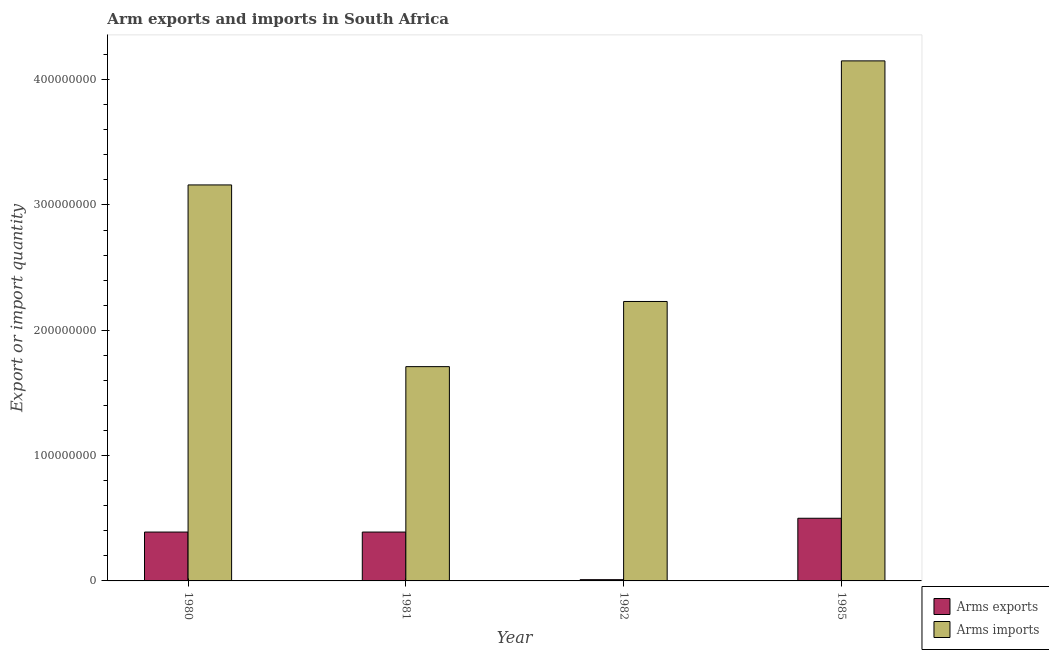How many groups of bars are there?
Provide a short and direct response. 4. Are the number of bars per tick equal to the number of legend labels?
Give a very brief answer. Yes. What is the label of the 3rd group of bars from the left?
Provide a short and direct response. 1982. What is the arms imports in 1981?
Make the answer very short. 1.71e+08. Across all years, what is the maximum arms imports?
Your response must be concise. 4.15e+08. Across all years, what is the minimum arms imports?
Offer a very short reply. 1.71e+08. In which year was the arms exports maximum?
Your answer should be very brief. 1985. In which year was the arms exports minimum?
Provide a short and direct response. 1982. What is the total arms imports in the graph?
Offer a terse response. 1.12e+09. What is the difference between the arms exports in 1980 and that in 1982?
Your answer should be very brief. 3.80e+07. What is the difference between the arms exports in 1981 and the arms imports in 1982?
Your answer should be compact. 3.80e+07. What is the average arms exports per year?
Give a very brief answer. 3.22e+07. In the year 1985, what is the difference between the arms exports and arms imports?
Your response must be concise. 0. In how many years, is the arms imports greater than 20000000?
Offer a terse response. 4. What is the ratio of the arms imports in 1982 to that in 1985?
Provide a succinct answer. 0.54. Is the arms exports in 1980 less than that in 1985?
Keep it short and to the point. Yes. What is the difference between the highest and the second highest arms exports?
Provide a short and direct response. 1.10e+07. What is the difference between the highest and the lowest arms imports?
Your answer should be very brief. 2.44e+08. In how many years, is the arms exports greater than the average arms exports taken over all years?
Make the answer very short. 3. What does the 1st bar from the left in 1981 represents?
Provide a succinct answer. Arms exports. What does the 2nd bar from the right in 1980 represents?
Give a very brief answer. Arms exports. How many bars are there?
Offer a terse response. 8. How many years are there in the graph?
Make the answer very short. 4. Are the values on the major ticks of Y-axis written in scientific E-notation?
Your answer should be compact. No. Does the graph contain any zero values?
Provide a short and direct response. No. Does the graph contain grids?
Your answer should be very brief. No. Where does the legend appear in the graph?
Keep it short and to the point. Bottom right. How many legend labels are there?
Keep it short and to the point. 2. How are the legend labels stacked?
Your answer should be very brief. Vertical. What is the title of the graph?
Your response must be concise. Arm exports and imports in South Africa. Does "Primary completion rate" appear as one of the legend labels in the graph?
Keep it short and to the point. No. What is the label or title of the X-axis?
Offer a terse response. Year. What is the label or title of the Y-axis?
Make the answer very short. Export or import quantity. What is the Export or import quantity of Arms exports in 1980?
Your answer should be compact. 3.90e+07. What is the Export or import quantity of Arms imports in 1980?
Your response must be concise. 3.16e+08. What is the Export or import quantity of Arms exports in 1981?
Ensure brevity in your answer.  3.90e+07. What is the Export or import quantity in Arms imports in 1981?
Provide a short and direct response. 1.71e+08. What is the Export or import quantity in Arms exports in 1982?
Give a very brief answer. 1.00e+06. What is the Export or import quantity of Arms imports in 1982?
Your answer should be compact. 2.23e+08. What is the Export or import quantity in Arms exports in 1985?
Your answer should be very brief. 5.00e+07. What is the Export or import quantity in Arms imports in 1985?
Ensure brevity in your answer.  4.15e+08. Across all years, what is the maximum Export or import quantity in Arms imports?
Give a very brief answer. 4.15e+08. Across all years, what is the minimum Export or import quantity in Arms exports?
Keep it short and to the point. 1.00e+06. Across all years, what is the minimum Export or import quantity in Arms imports?
Provide a short and direct response. 1.71e+08. What is the total Export or import quantity in Arms exports in the graph?
Keep it short and to the point. 1.29e+08. What is the total Export or import quantity in Arms imports in the graph?
Offer a terse response. 1.12e+09. What is the difference between the Export or import quantity of Arms exports in 1980 and that in 1981?
Ensure brevity in your answer.  0. What is the difference between the Export or import quantity in Arms imports in 1980 and that in 1981?
Your answer should be compact. 1.45e+08. What is the difference between the Export or import quantity of Arms exports in 1980 and that in 1982?
Make the answer very short. 3.80e+07. What is the difference between the Export or import quantity of Arms imports in 1980 and that in 1982?
Provide a short and direct response. 9.30e+07. What is the difference between the Export or import quantity of Arms exports in 1980 and that in 1985?
Ensure brevity in your answer.  -1.10e+07. What is the difference between the Export or import quantity in Arms imports in 1980 and that in 1985?
Provide a short and direct response. -9.90e+07. What is the difference between the Export or import quantity of Arms exports in 1981 and that in 1982?
Your response must be concise. 3.80e+07. What is the difference between the Export or import quantity in Arms imports in 1981 and that in 1982?
Provide a short and direct response. -5.20e+07. What is the difference between the Export or import quantity in Arms exports in 1981 and that in 1985?
Give a very brief answer. -1.10e+07. What is the difference between the Export or import quantity in Arms imports in 1981 and that in 1985?
Your answer should be very brief. -2.44e+08. What is the difference between the Export or import quantity of Arms exports in 1982 and that in 1985?
Ensure brevity in your answer.  -4.90e+07. What is the difference between the Export or import quantity in Arms imports in 1982 and that in 1985?
Keep it short and to the point. -1.92e+08. What is the difference between the Export or import quantity of Arms exports in 1980 and the Export or import quantity of Arms imports in 1981?
Your response must be concise. -1.32e+08. What is the difference between the Export or import quantity of Arms exports in 1980 and the Export or import quantity of Arms imports in 1982?
Give a very brief answer. -1.84e+08. What is the difference between the Export or import quantity of Arms exports in 1980 and the Export or import quantity of Arms imports in 1985?
Ensure brevity in your answer.  -3.76e+08. What is the difference between the Export or import quantity in Arms exports in 1981 and the Export or import quantity in Arms imports in 1982?
Ensure brevity in your answer.  -1.84e+08. What is the difference between the Export or import quantity in Arms exports in 1981 and the Export or import quantity in Arms imports in 1985?
Keep it short and to the point. -3.76e+08. What is the difference between the Export or import quantity of Arms exports in 1982 and the Export or import quantity of Arms imports in 1985?
Ensure brevity in your answer.  -4.14e+08. What is the average Export or import quantity of Arms exports per year?
Your answer should be compact. 3.22e+07. What is the average Export or import quantity in Arms imports per year?
Provide a short and direct response. 2.81e+08. In the year 1980, what is the difference between the Export or import quantity in Arms exports and Export or import quantity in Arms imports?
Give a very brief answer. -2.77e+08. In the year 1981, what is the difference between the Export or import quantity in Arms exports and Export or import quantity in Arms imports?
Offer a very short reply. -1.32e+08. In the year 1982, what is the difference between the Export or import quantity of Arms exports and Export or import quantity of Arms imports?
Offer a terse response. -2.22e+08. In the year 1985, what is the difference between the Export or import quantity of Arms exports and Export or import quantity of Arms imports?
Ensure brevity in your answer.  -3.65e+08. What is the ratio of the Export or import quantity of Arms exports in 1980 to that in 1981?
Your answer should be very brief. 1. What is the ratio of the Export or import quantity of Arms imports in 1980 to that in 1981?
Your response must be concise. 1.85. What is the ratio of the Export or import quantity in Arms imports in 1980 to that in 1982?
Give a very brief answer. 1.42. What is the ratio of the Export or import quantity of Arms exports in 1980 to that in 1985?
Your answer should be compact. 0.78. What is the ratio of the Export or import quantity in Arms imports in 1980 to that in 1985?
Make the answer very short. 0.76. What is the ratio of the Export or import quantity of Arms imports in 1981 to that in 1982?
Give a very brief answer. 0.77. What is the ratio of the Export or import quantity of Arms exports in 1981 to that in 1985?
Keep it short and to the point. 0.78. What is the ratio of the Export or import quantity of Arms imports in 1981 to that in 1985?
Make the answer very short. 0.41. What is the ratio of the Export or import quantity in Arms exports in 1982 to that in 1985?
Make the answer very short. 0.02. What is the ratio of the Export or import quantity in Arms imports in 1982 to that in 1985?
Your response must be concise. 0.54. What is the difference between the highest and the second highest Export or import quantity in Arms exports?
Your response must be concise. 1.10e+07. What is the difference between the highest and the second highest Export or import quantity of Arms imports?
Your response must be concise. 9.90e+07. What is the difference between the highest and the lowest Export or import quantity in Arms exports?
Make the answer very short. 4.90e+07. What is the difference between the highest and the lowest Export or import quantity of Arms imports?
Keep it short and to the point. 2.44e+08. 